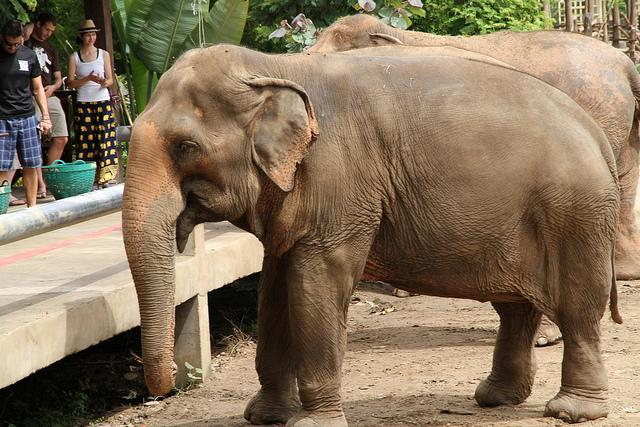What is this place? Please explain your reasoning. zoo. The elephants are standing in an enclosure at a zoo. 